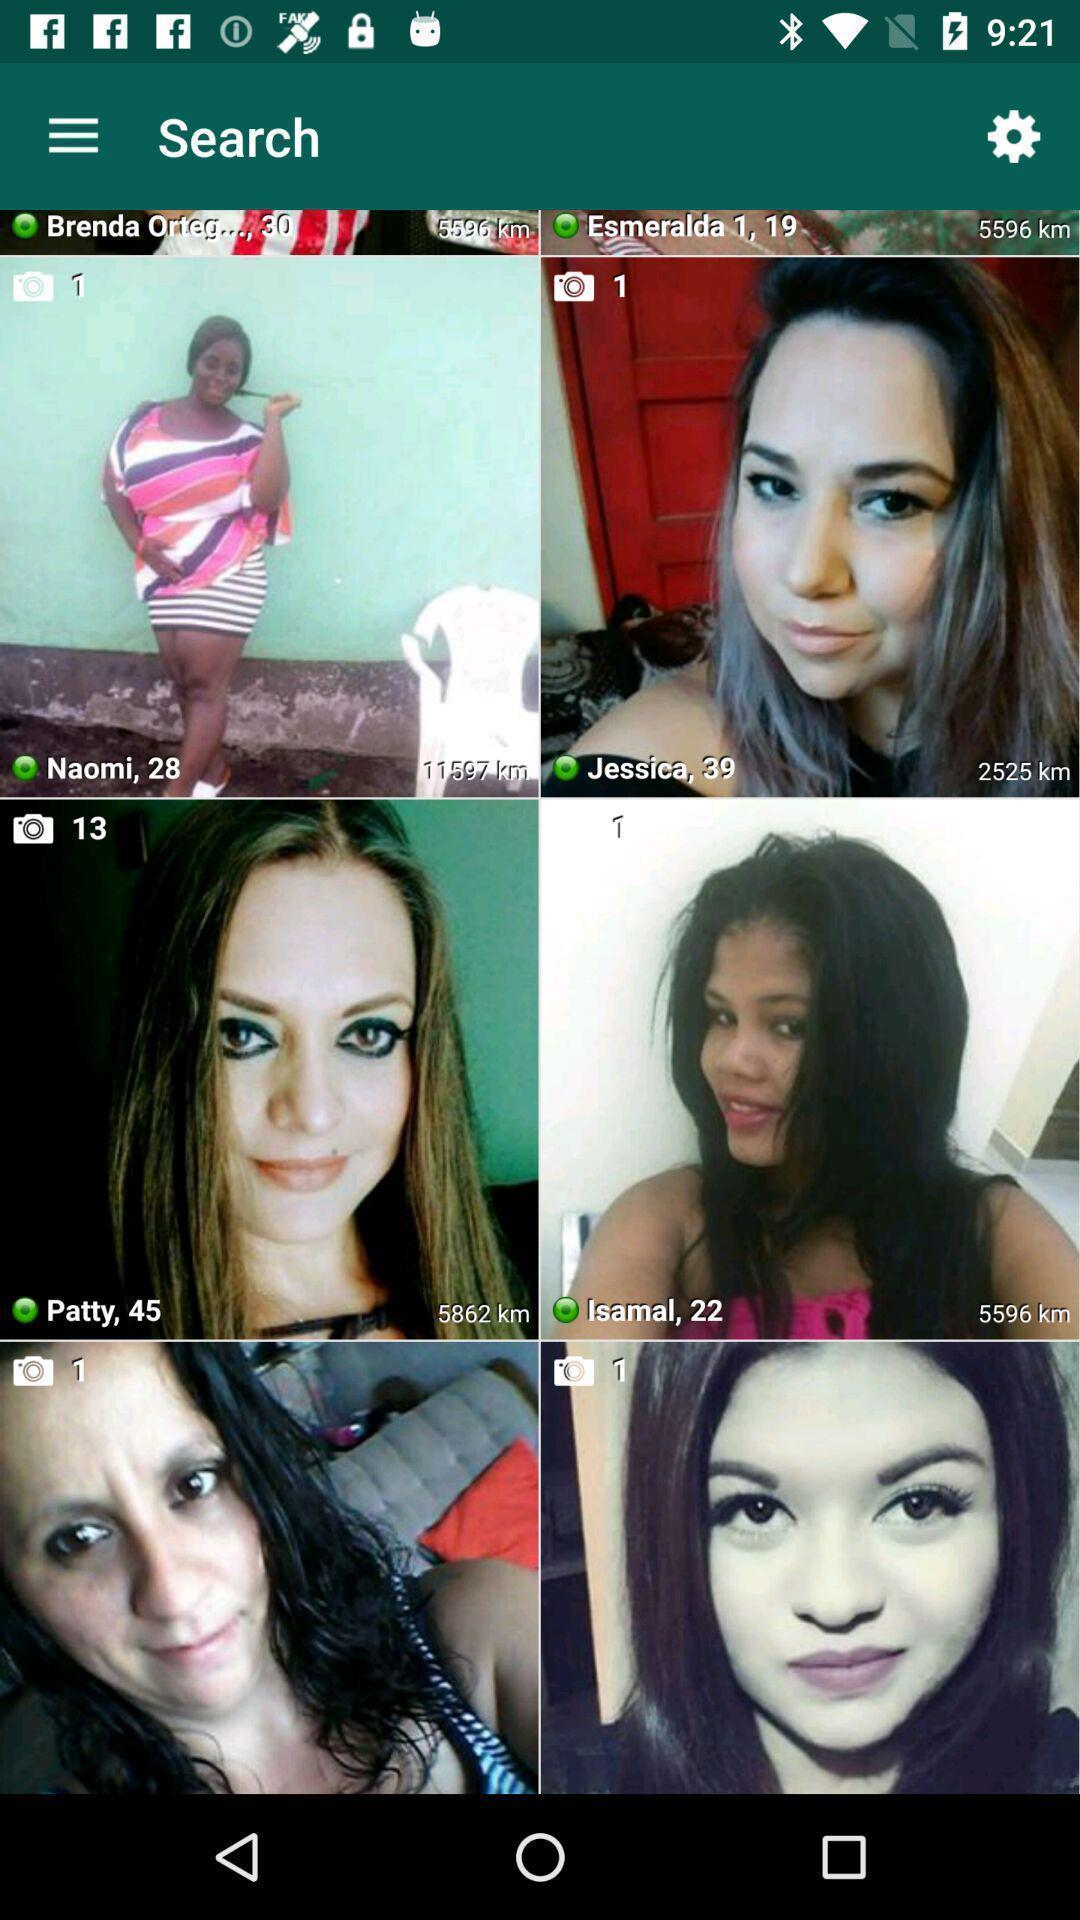Explain the elements present in this screenshot. Screen shows multiple profile pics in communication app. 